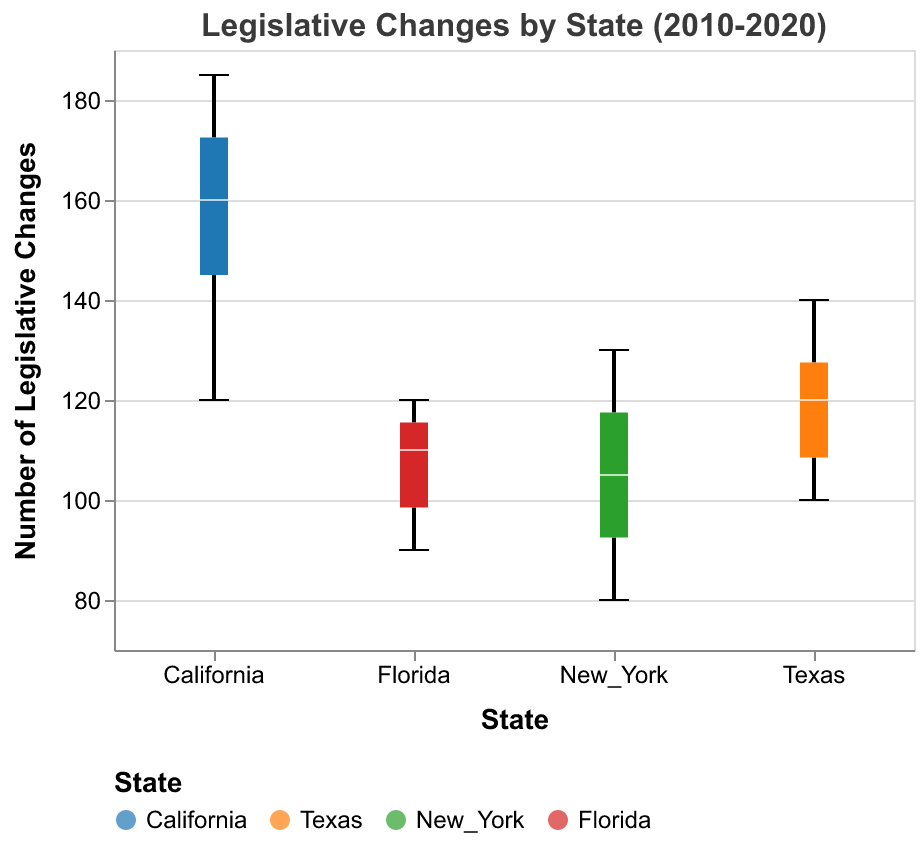What is the title of the plot? The title is positioned at the top of the plot and provides a summary of what the plot represents. In this case, it reads, "Legislative Changes by State (2010-2020)."
Answer: Legislative Changes by State (2010-2020) Which state has the highest median value of legislative changes? By looking at the central line (median) within each box, we can see that California's median line is higher than those of Texas, New York, and Florida.
Answer: California What is the minimum number of legislative changes in New York? The lower whisker of the boxplot for New York represents the minimum number, which corresponds to the lowest legislative change. The figure shows this value around 80.
Answer: 80 Which state has the greatest range of legislative changes? The range is the difference between the maximum and minimum values shown by the whiskers. California, with its whiskers spanning from around 120 to 185, has the greatest range.
Answer: California Which state shows the smallest variance in legislative changes? Variance is visually assessed by the spread of the box. New York's box is the tightest, suggesting the smallest variance in legislative changes.
Answer: New York What is the interquartile range (IQR) of legislative changes in Texas? The IQR is the range of the middle 50% of the data, represented by the box itself. In Texas, the top of the box (Q3) is around 125, and the bottom (Q1) is around 107. The IQR is 125 - 107 = 18.
Answer: 18 Is California's median value of legislative changes higher than the maximum value in Florida? By comparing the median line in California and the upper whisker in Florida, it is evident that California's median is around 160, which is higher than Florida's maximum of about 120.
Answer: Yes What is the difference between the median legislative changes of California and New York? Looking at the central line in the boxes, California's median is around 160, while New York's median is approximately 105. The difference is 160 - 105 = 55.
Answer: 55 What are the maximum legislative changes observed in Texas? The upper whisker of Texas's boxplot shows the highest value, which is around 140.
Answer: 140 